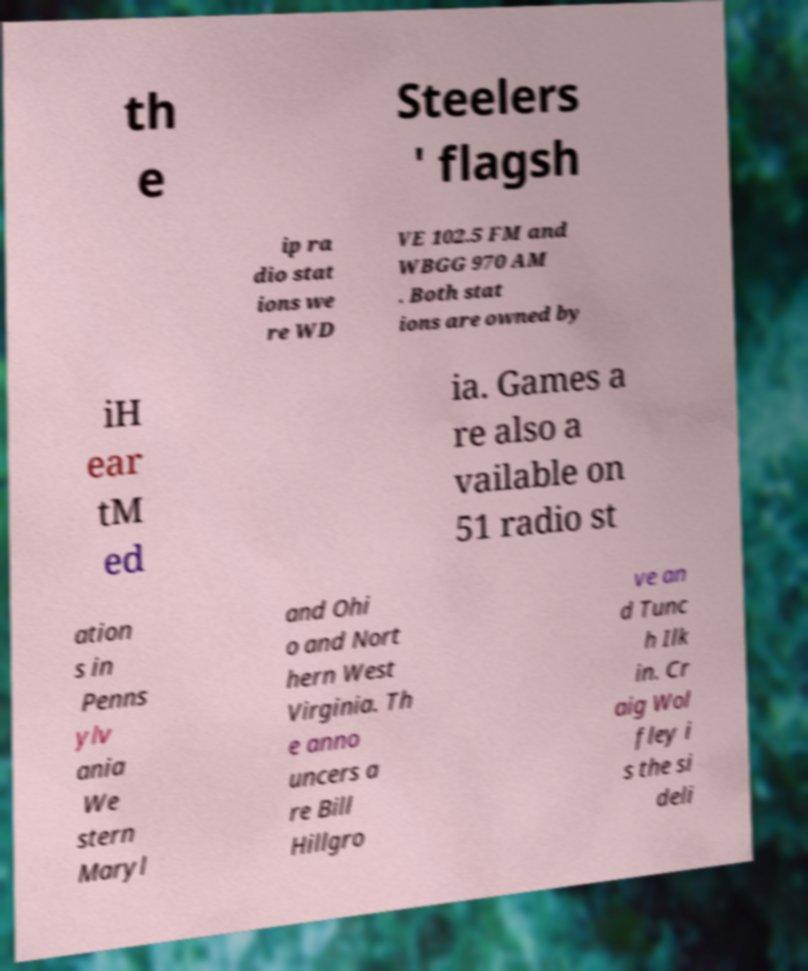Could you extract and type out the text from this image? th e Steelers ' flagsh ip ra dio stat ions we re WD VE 102.5 FM and WBGG 970 AM . Both stat ions are owned by iH ear tM ed ia. Games a re also a vailable on 51 radio st ation s in Penns ylv ania We stern Maryl and Ohi o and Nort hern West Virginia. Th e anno uncers a re Bill Hillgro ve an d Tunc h Ilk in. Cr aig Wol fley i s the si deli 